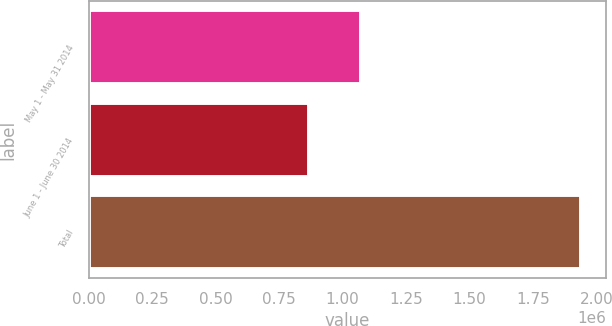Convert chart to OTSL. <chart><loc_0><loc_0><loc_500><loc_500><bar_chart><fcel>May 1 - May 31 2014<fcel>June 1 - June 30 2014<fcel>Total<nl><fcel>1.07305e+06<fcel>867960<fcel>1.94101e+06<nl></chart> 